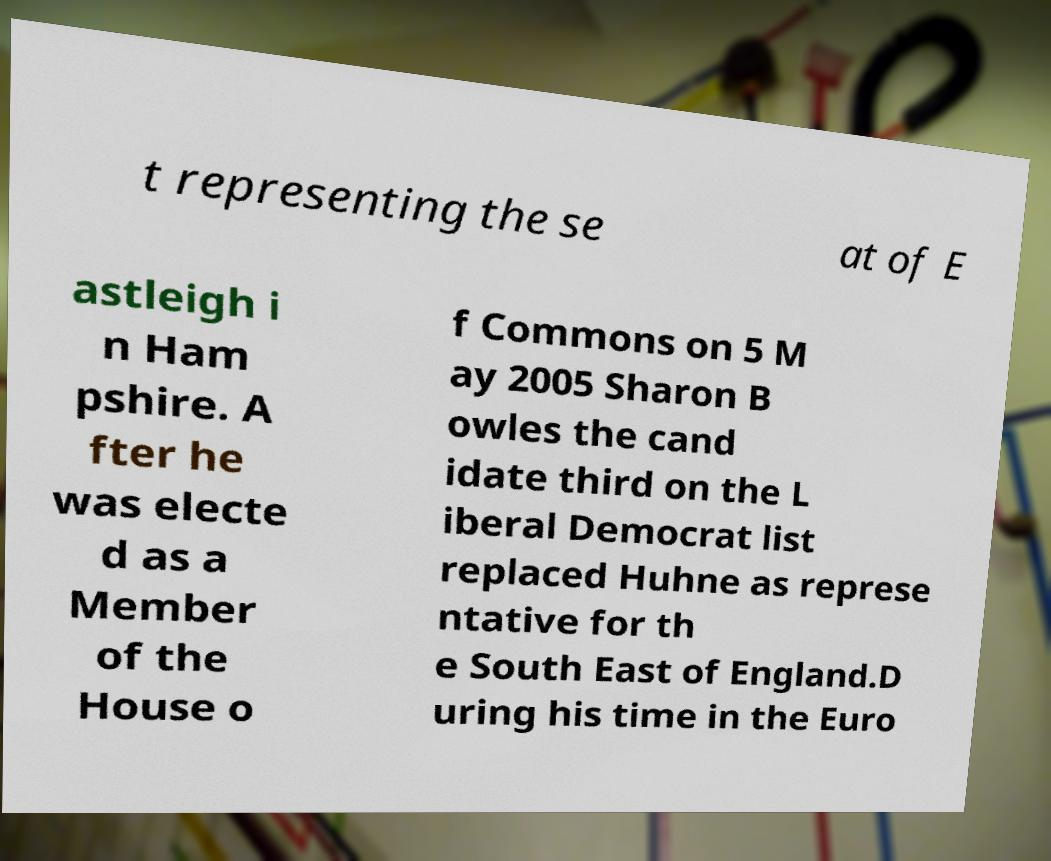What messages or text are displayed in this image? I need them in a readable, typed format. t representing the se at of E astleigh i n Ham pshire. A fter he was electe d as a Member of the House o f Commons on 5 M ay 2005 Sharon B owles the cand idate third on the L iberal Democrat list replaced Huhne as represe ntative for th e South East of England.D uring his time in the Euro 